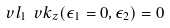Convert formula to latex. <formula><loc_0><loc_0><loc_500><loc_500>\ v l _ { 1 } \ v k _ { z } ( \epsilon _ { 1 } = 0 , \epsilon _ { 2 } ) = 0</formula> 